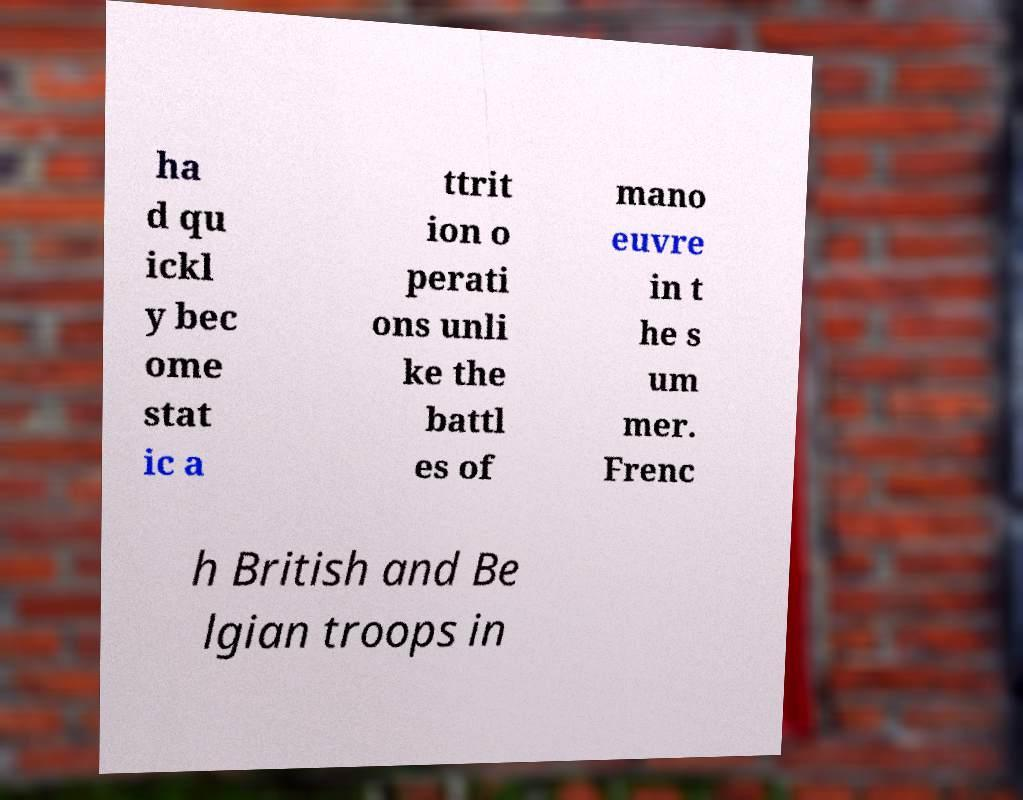Please read and relay the text visible in this image. What does it say? ha d qu ickl y bec ome stat ic a ttrit ion o perati ons unli ke the battl es of mano euvre in t he s um mer. Frenc h British and Be lgian troops in 